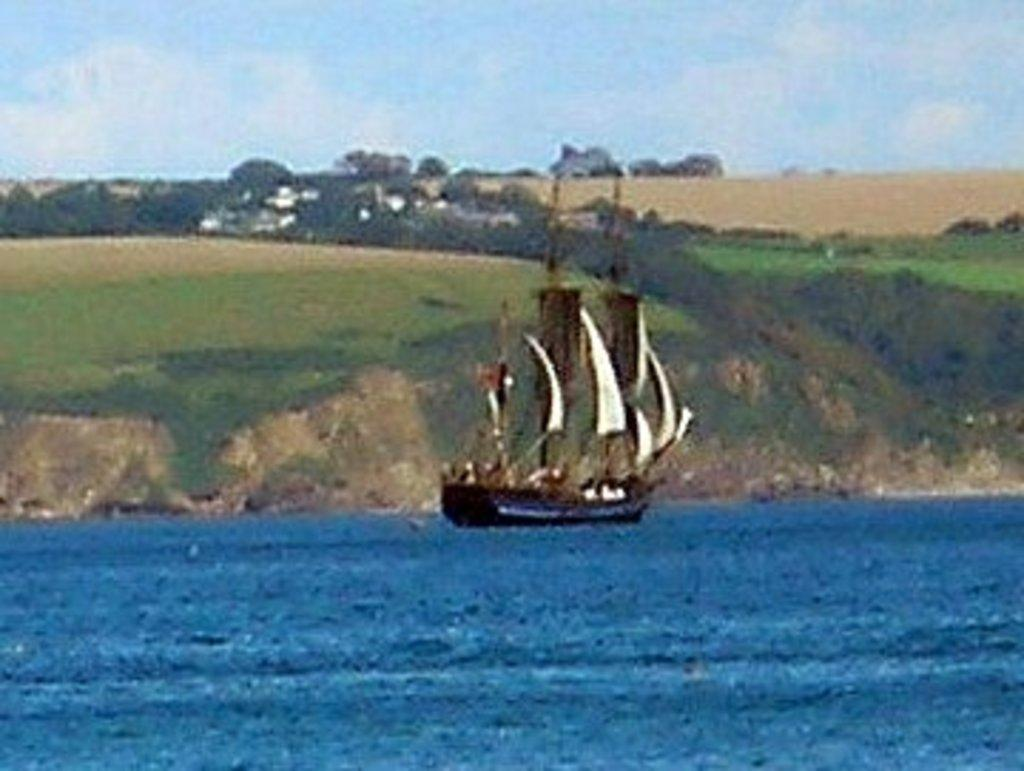What is the main subject of the image? The main subject of the image is a boat. Where is the boat located? The boat is on the water. What can be seen in the background of the image? There are trees and the sky visible in the background of the image. What type of fuel is being used by the boat in the image? There is no information about the type of fuel being used by the boat in the image. Can you see a net and a hook in the image? No, there is no net or hook present in the image. 